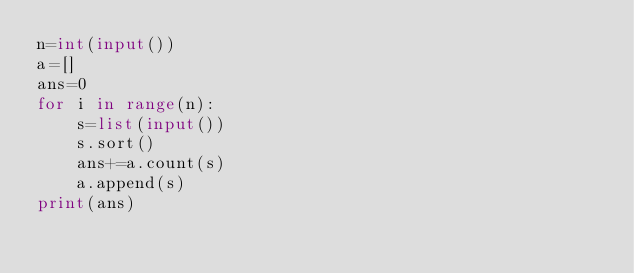Convert code to text. <code><loc_0><loc_0><loc_500><loc_500><_Python_>n=int(input())
a=[]
ans=0
for i in range(n):
    s=list(input())
    s.sort()
    ans+=a.count(s)
    a.append(s)
print(ans)
</code> 